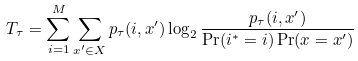Convert formula to latex. <formula><loc_0><loc_0><loc_500><loc_500>T _ { \tau } = \sum _ { i = 1 } ^ { M } \sum _ { { x ^ { \prime } } \in X } p _ { \tau } ( i , { x ^ { \prime } } ) \log _ { 2 } \frac { p _ { \tau } ( i , { x ^ { \prime } } ) } { \Pr ( i ^ { \ast } = i ) \Pr ( { x } = { x ^ { \prime } } ) }</formula> 